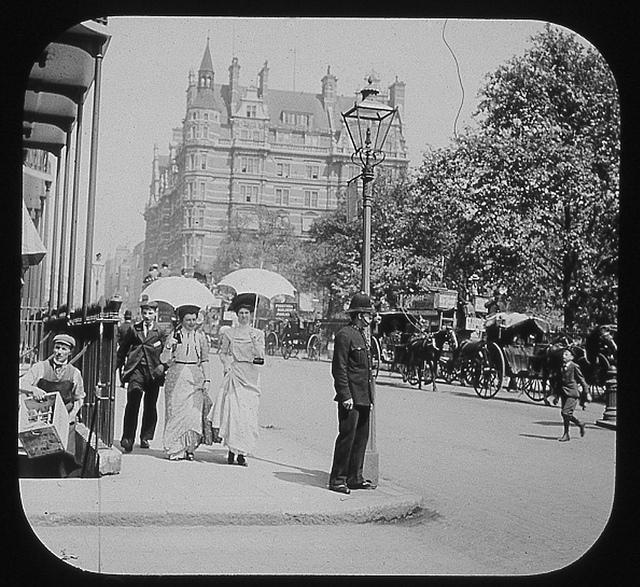How many girls do you see that is wearing a hat?
Be succinct. 2. What year was this?
Be succinct. 1930. Are the ladies going for a walk?
Be succinct. Yes. Is this an old image?
Concise answer only. Yes. 